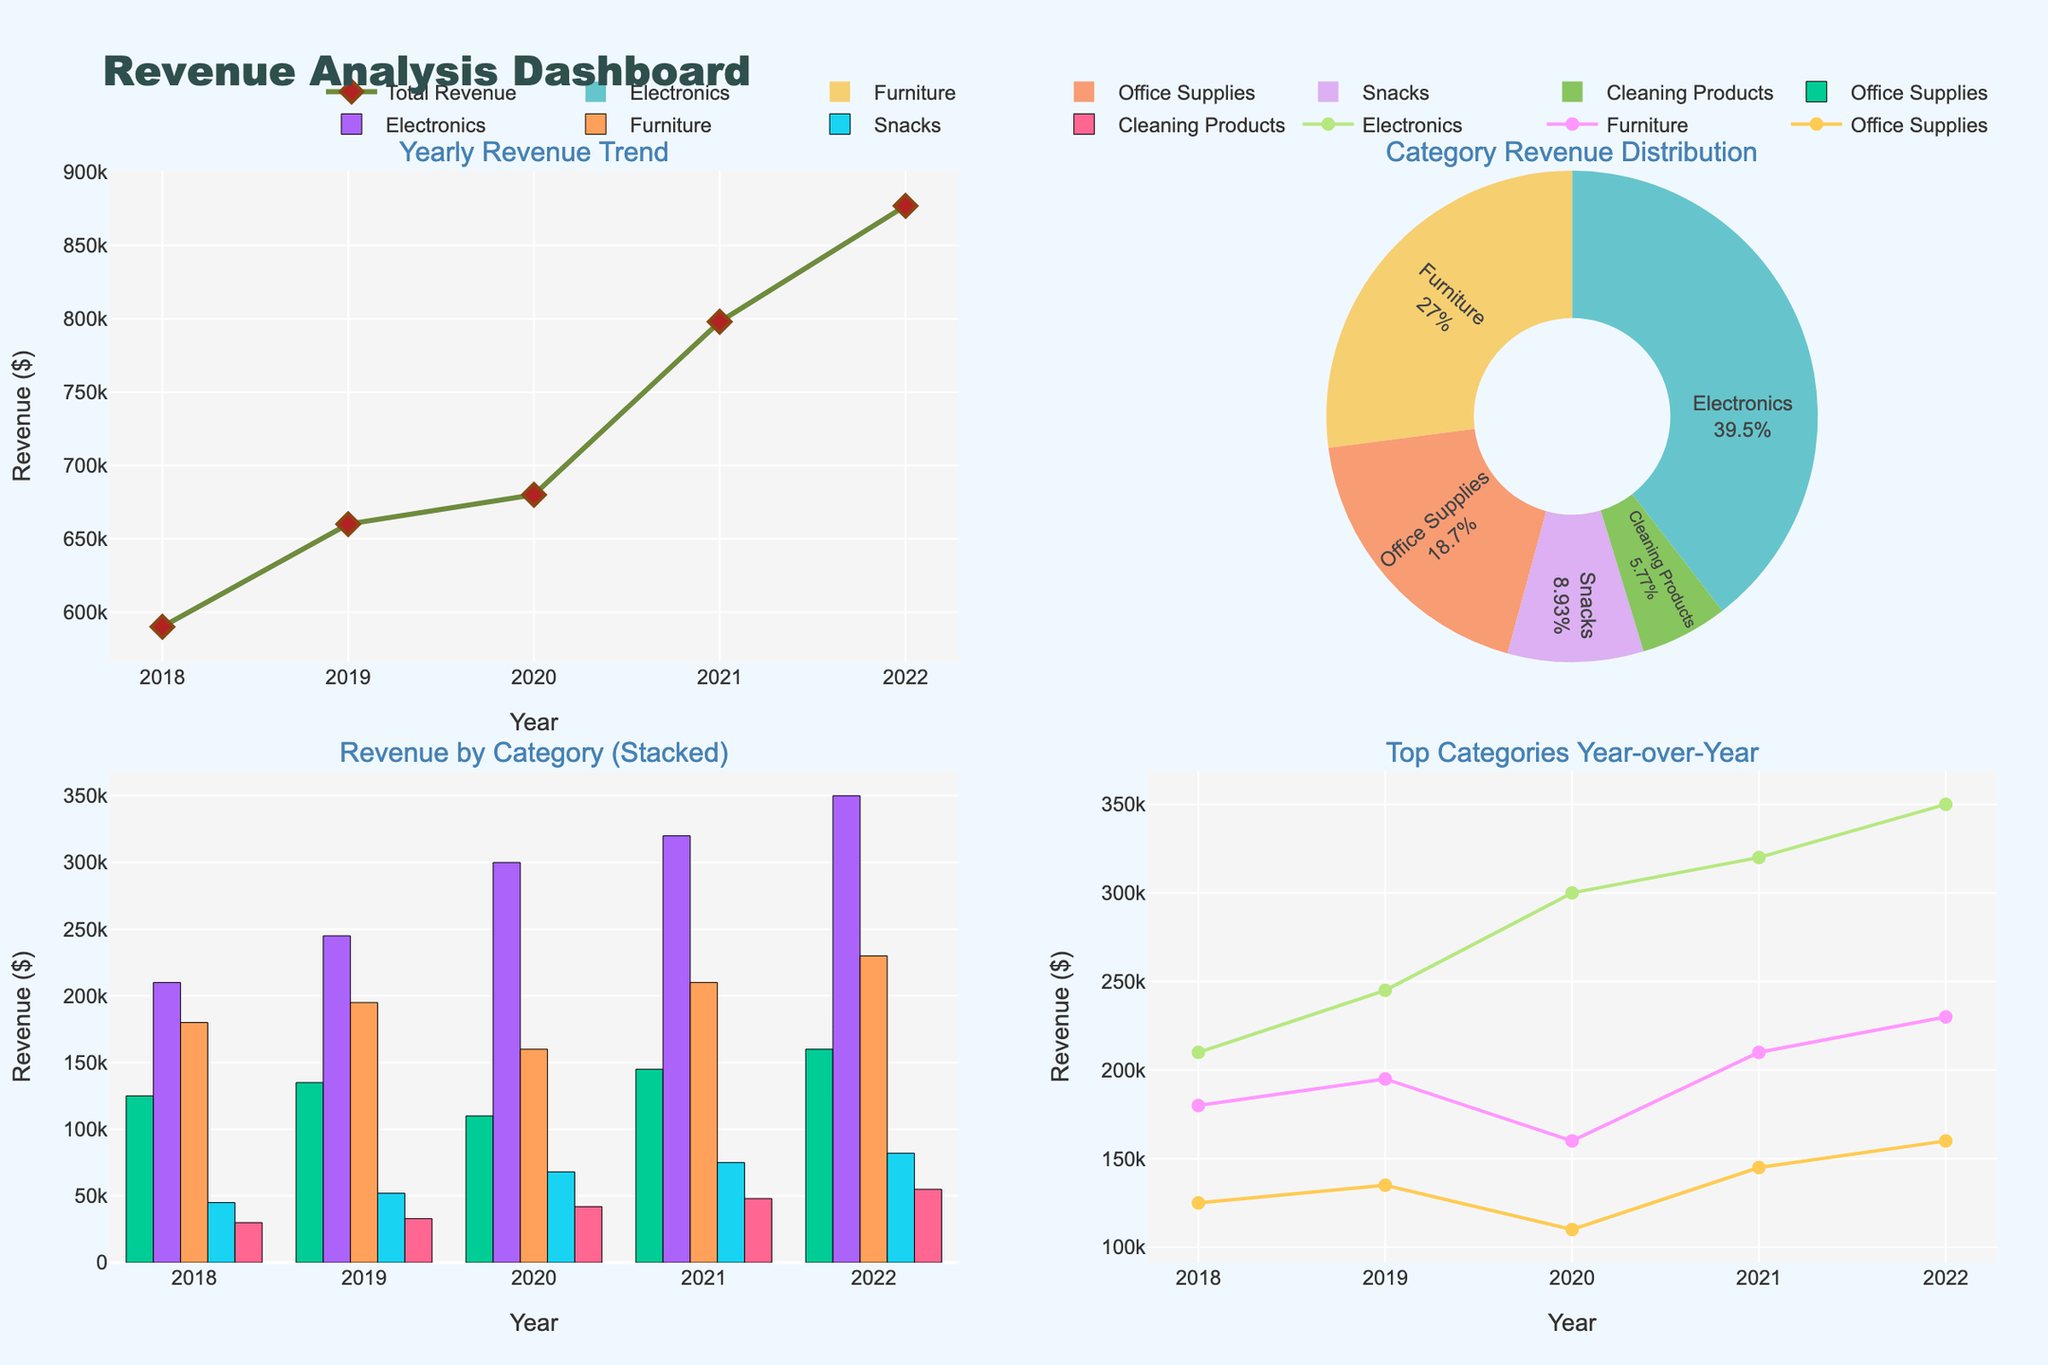What is the total revenue for the year 2020? Look at the line chart titled "Yearly Revenue Trend". Identify the revenue value on the y-axis corresponding to the year 2020 on the x-axis.
Answer: 680,000 Which category had the highest total revenue over the past 5 years? Refer to the pie chart titled "Category Revenue Distribution". The category with the largest pie slice represents the highest total revenue.
Answer: Electronics How did the revenue for office supplies change from 2020 to 2021? On the "Revenue by Category (Stacked)" chart, locate Office Supplies and compare the 2020 and 2021 bars. Calculate the difference: 2021 revenue minus 2020 revenue.
Answer: Increased by 35,000 Which category shows the most consistent growth year-over-year in the "Top Categories Year-over-Year" chart? Look at the line chart comparing Office Supplies, Electronics, and Furniture. Consistency is indicated by a steady increase without fluctuations for a category.
Answer: Electronics What percentage of the total revenue in 2022 was generated by Snacks? Use the yearly revenue for 2022 from the "Yearly Revenue Trend" and the Snacks revenue from "Revenue by Category (Stacked)". Calculate the percentage: (Snacks revenue / Total revenue) * 100%.
Answer: ~8.2% In which year did Cleaning Products see its highest revenue? Refer to the "Revenue by Category (Stacked)" chart and identify the year with the tallest bar for Cleaning Products.
Answer: 2022 How does the trend of total revenue compare to the trend of Electronics revenue over the past 5 years? Compare the lines in the "Yearly Revenue Trend" and the Electronics line in "Top Categories Year-over-Year". Note if they follow similar upward, downward, or fluctuating patterns.
Answer: Both show a consistent upward trend What can be inferred about the relative importance of Furniture in terms of revenue in 2020 compared to 2018? Refer to both the "Revenue by Category (Stacked)" and "Top Categories Year-over-Year". Compare the height of the bars and the lines for Furniture in 2020 and 2018.
Answer: Decreased importance Which years can be identified as having the lowest and highest total revenue respectively? Look at the "Yearly Revenue Trend" and identify the minimum and maximum points in the line chart.
Answer: Lowest: 2020, Highest: 2022 Did Snacks ever surpass Office Supplies in revenue in any year? Compare the bars for Snacks to Office Supplies in the "Revenue by Category (Stacked)" chart for each year from 2018 to 2022.
Answer: No 